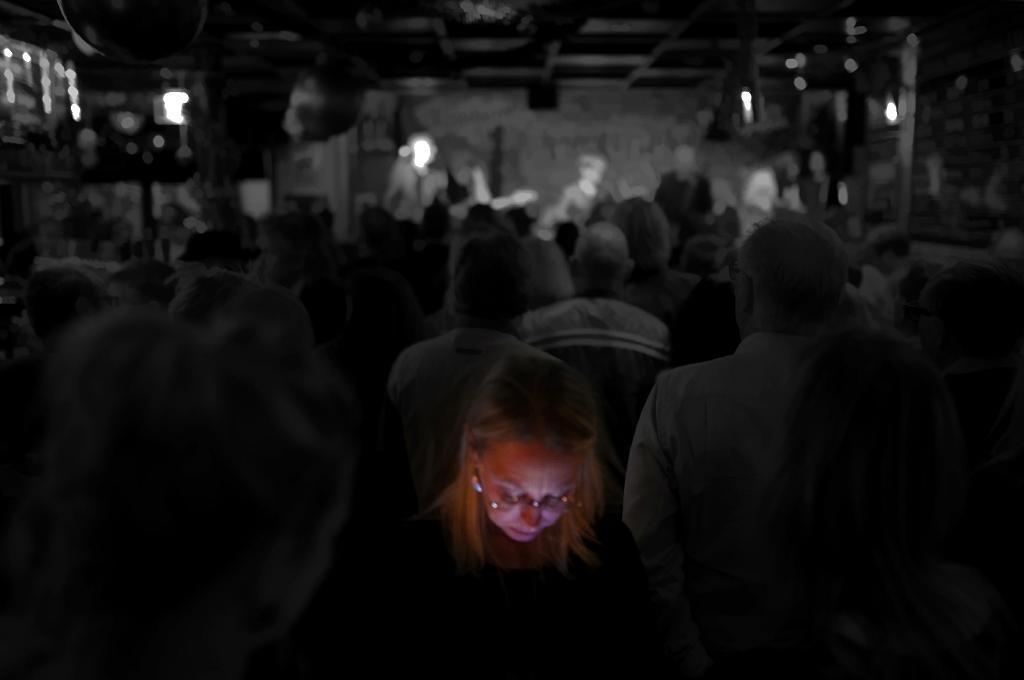What is the main subject of the image? There is a person with a light on her face in the image. How many people are present in the image? There are many people in the image. Can you describe the background of the image? The background of the image is slightly blurred. What type of receipt can be seen in the hands of the person with the light on her face? There is no receipt present in the image; the person has a light on her face. How many dogs are visible in the image? There are no dogs present in the image. 